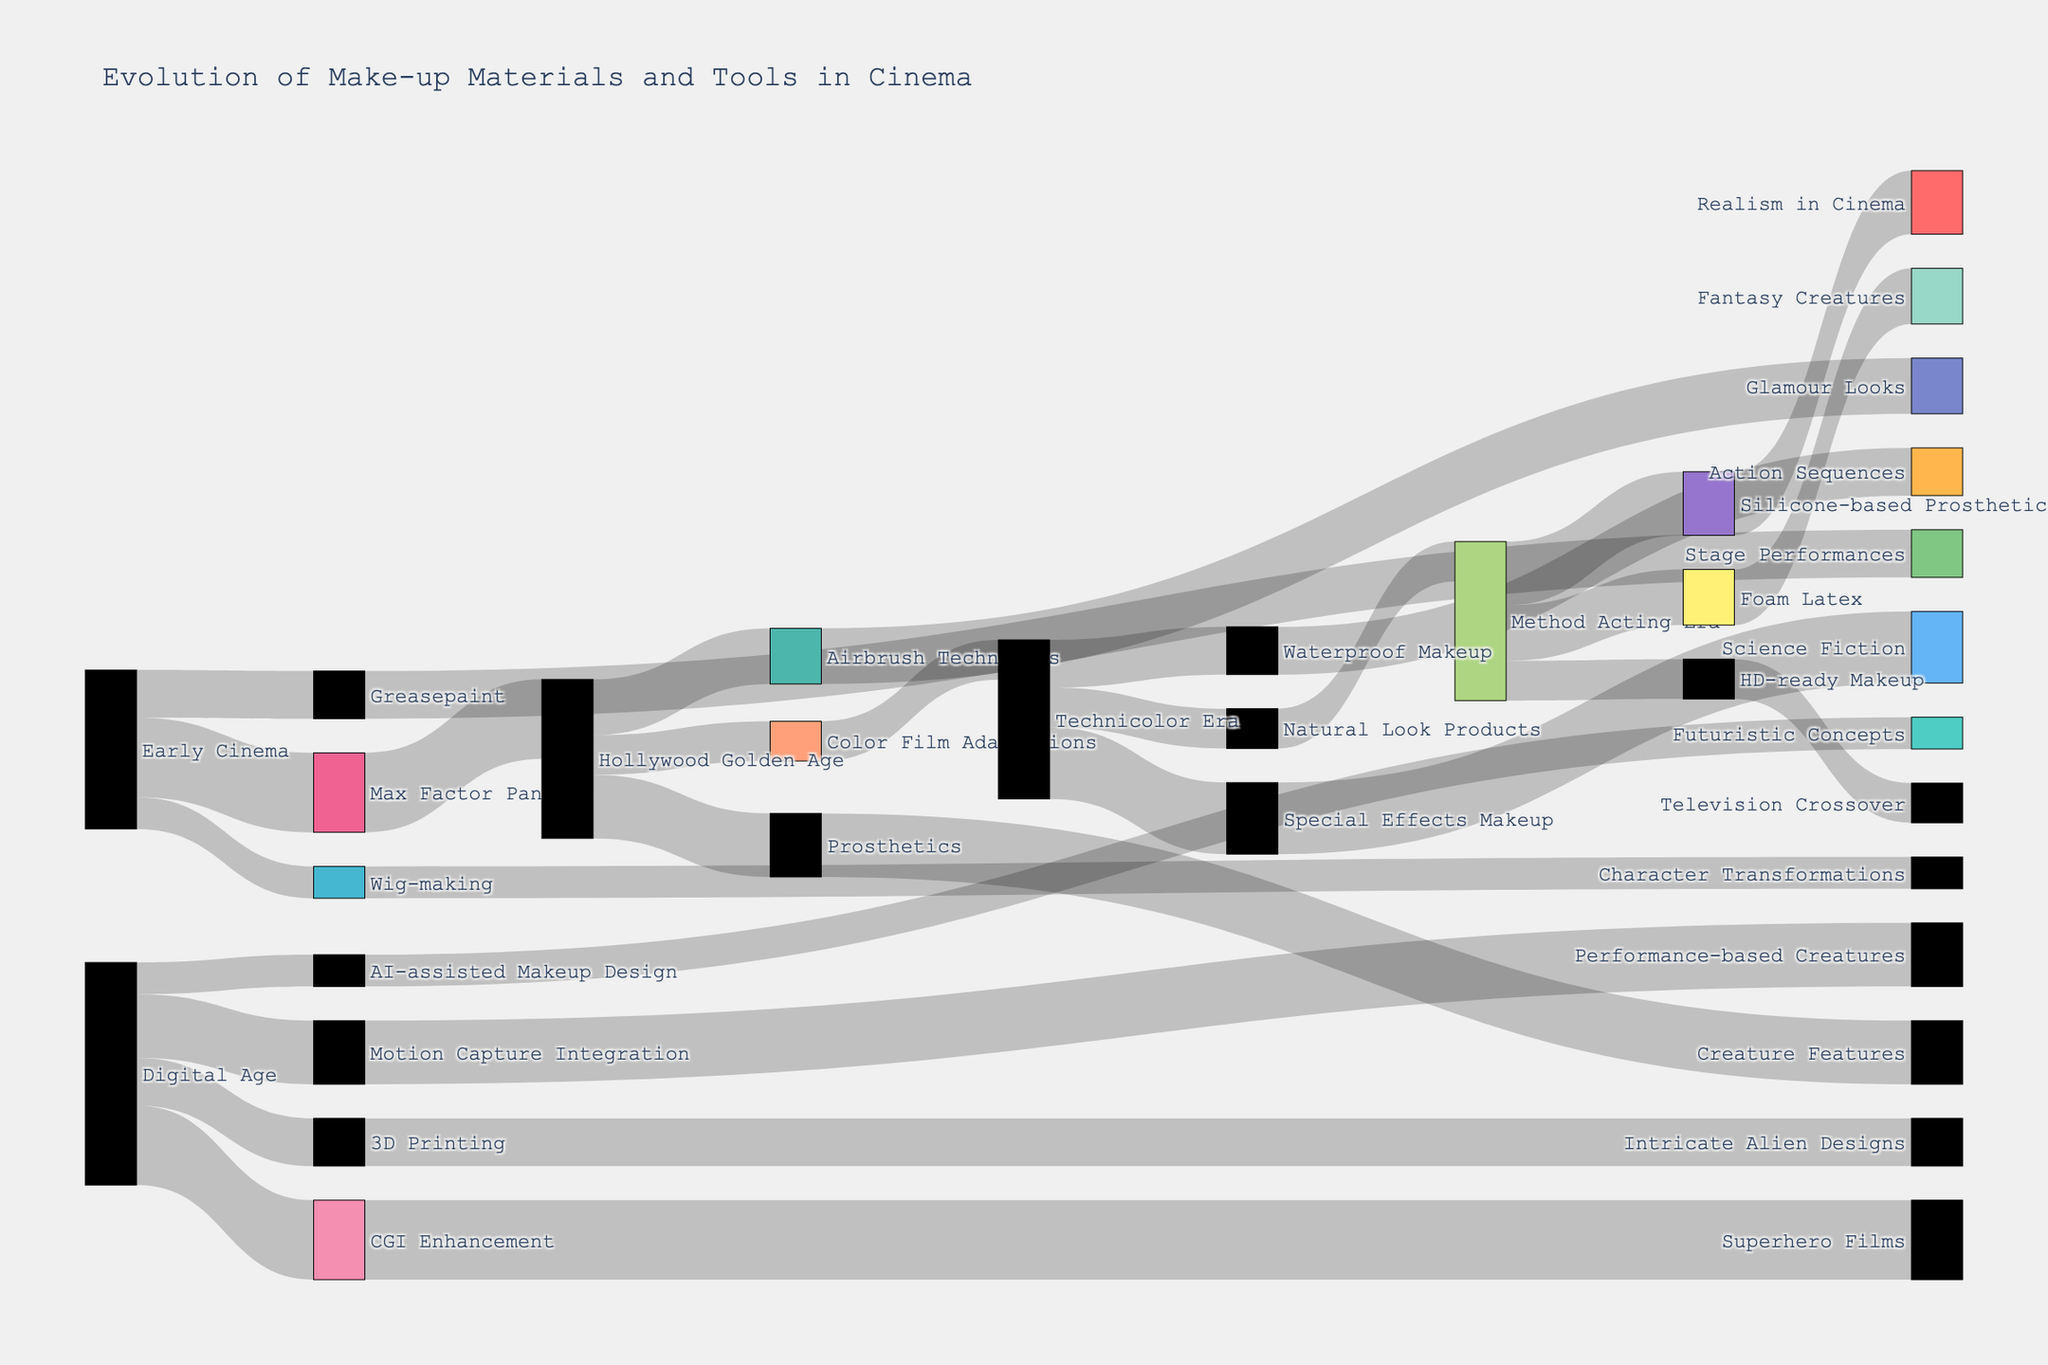what is the title of the Sankey diagram? The title of the Sankey diagram is easy to identify as it is usually placed at the top of the figure and generally uses larger or bold font to draw attention.
Answer: Evolution of Make-up Materials and Tools in Cinema What makeup materials and tools evolved from the Early Cinema era? To answer this, look at the source node labeled "Early Cinema" and trace all outgoing flows to intermediate nodes, which represent makeup materials and tools.
Answer: Greasepaint, Max Factor Pancake, Wig-making Which era provided the most directly connected makeup materials and tools to other categories? Observe the Sankey diagram to see which era has the maximum number of flows coming out of it and leading to intermediate makeup materials and tools.
Answer: Hollywood Golden Age How many transitions lead from the Method Acting Era to other categories? Starting from the Method Acting Era node, count the number of paths or transitions that flow to various target nodes.
Answer: Three What is the sum of the values for transitions originating from the Hollywood Golden Age era? Identify all outgoing flows from "Hollywood Golden Age," and then sum their respective values. Values are: 40 (Prosthetics), 35 (Airbrush Techniques), 25 (Color Film Adaptations). Sum = 40 + 35 + 25 = 100.
Answer: 100 Which category has the largest individual flow value associated with it, and what is that value? Review all the link values in the Sankey diagram to see which flow has the highest numerical value. The largest is the 50 units from Early Cinema to Max Factor Pancake and from Digital Age to CGI Enhancement.
Answer: Early Cinema to Max Factor Pancake, Digital Age to CGI Enhancement (50) What intermediate step is associated with both "Fantasy Creatures" and "Realism in Cinema"? Trace the flows that lead to both "Fantasy Creatures" and "Realism in Cinema" and identify the common intermediate node.
Answer: Silicone-based Prosthetics Compare the values of Prosthetics in "Creature Features" and Silicone-based Prosthetics in "Realism in Cinema". Identify the values of links leading to "Creature Features" from Prosthetics (40) and to "Realism in Cinema" from Silicone-based Prosthetics (40), and compare them.
Answer: Equal (both 40) How many target categories are influenced by Airbrush Techniques? Follow the flow from "Airbrush Techniques" and count the number of distinct nodes it connects to in the "Target" column.
Answer: One (Glamour Looks) From which stages did the "Natural Look Products" emerge as an intermediary before reaching its final target? Trace back from the "Natural Look Products" label to its preceding stages in the Sankey diagram.
Answer: Technicolor Era 